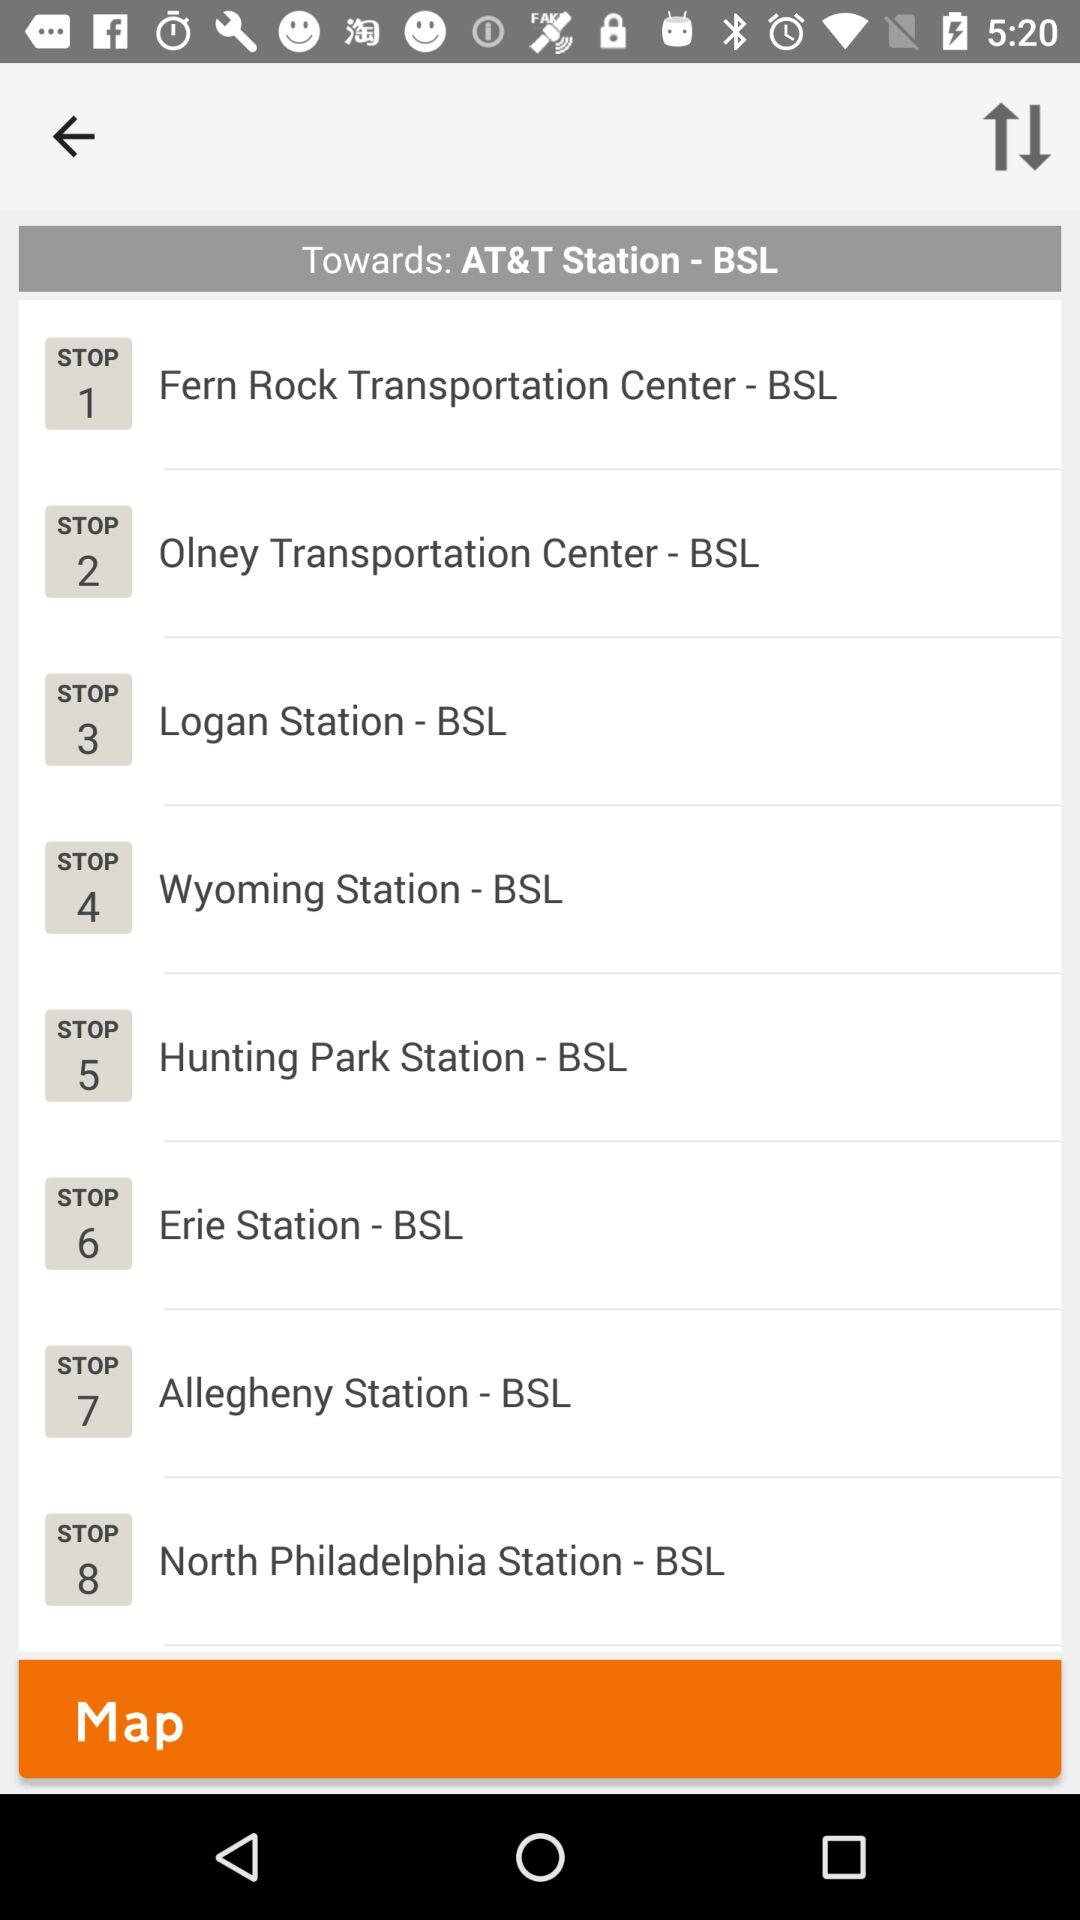What's the 1st stop? The first stop is "Fern Rock Transportation Center - BSL". 